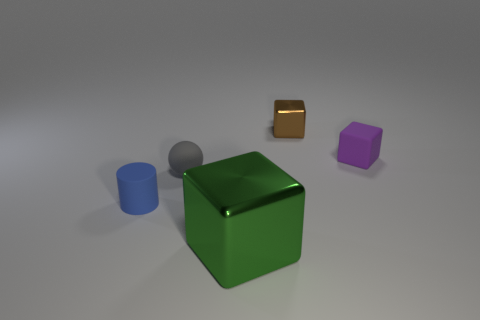Add 2 small brown metallic spheres. How many objects exist? 7 Subtract all tiny brown metal blocks. How many blocks are left? 2 Subtract all balls. How many objects are left? 4 Subtract 1 cylinders. How many cylinders are left? 0 Subtract all red spheres. Subtract all purple cubes. How many spheres are left? 1 Subtract all yellow spheres. How many brown cubes are left? 1 Subtract all small rubber cylinders. Subtract all tiny rubber objects. How many objects are left? 1 Add 1 spheres. How many spheres are left? 2 Add 4 tiny matte balls. How many tiny matte balls exist? 5 Subtract 0 blue cubes. How many objects are left? 5 